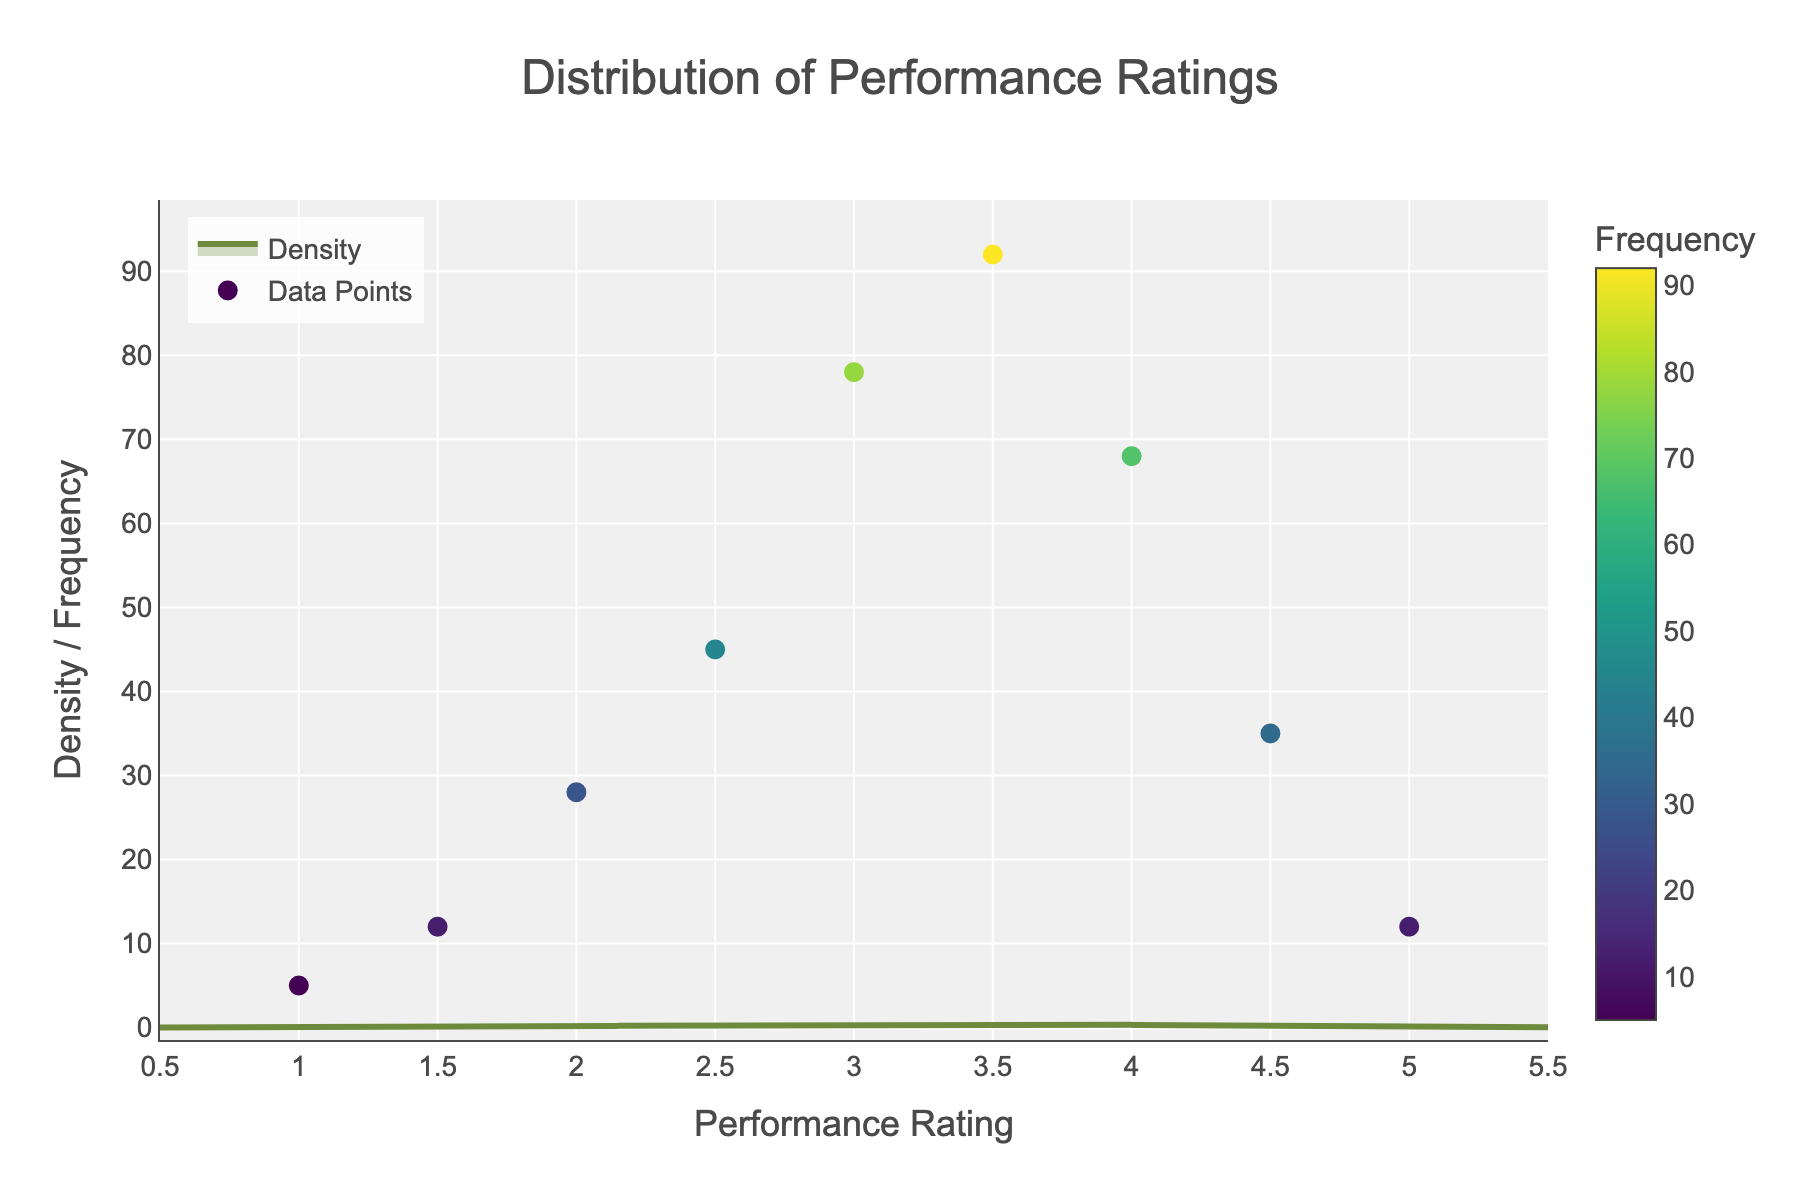What is the title of the plot? The plot has a title displayed at the top of the figure that reads 'Distribution of Performance Ratings'.
Answer: Distribution of Performance Ratings What does the x-axis represent? The x-axis label specifies that it represents 'Performance Rating'.
Answer: Performance Rating How many data points are shown in the scatter plot? Counting the distinct ratings marked with frequency values in the scatter plot, there are 9 data points.
Answer: 9 Which performance rating has the highest frequency? Looking at both the scatter plot and the color gradient, the performance rating of 3.5 has the highest frequency, shown in the figure.
Answer: 3.5 What range does the x-axis cover? The visible range of the x-axis starts from 0.5 to 5.5 as shown in the figure.
Answer: 0.5 to 5.5 At what rating does the density plot peak? The highest point of the density curve is around a rating of 3.5, indicating the mode.
Answer: 3.5 Compare the density at rating 2.5 and 4. Which is higher? Observing the density curve, the density at rating 2.5 is higher than at rating 4.
Answer: Density at 2.5 is higher What colors are used for the scatter points, and do they indicate anything? The scatter points use a 'Viridis' colorscale, where different colors represent different frequencies, with a color bar indicating frequency.
Answer: Viridis colors, indicating frequency What is the frequency at a performance rating of 5? The specific data point at rating 5 shows a frequency value of 12.
Answer: 12 How does the density change as the rating goes from 1 to 5? Initially, the density increases, peaks around 3.5, and then decreases as it approaches rating 5.
Answer: Increases, peaks at 3.5, then decreases 